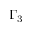<formula> <loc_0><loc_0><loc_500><loc_500>\Gamma _ { 3 }</formula> 